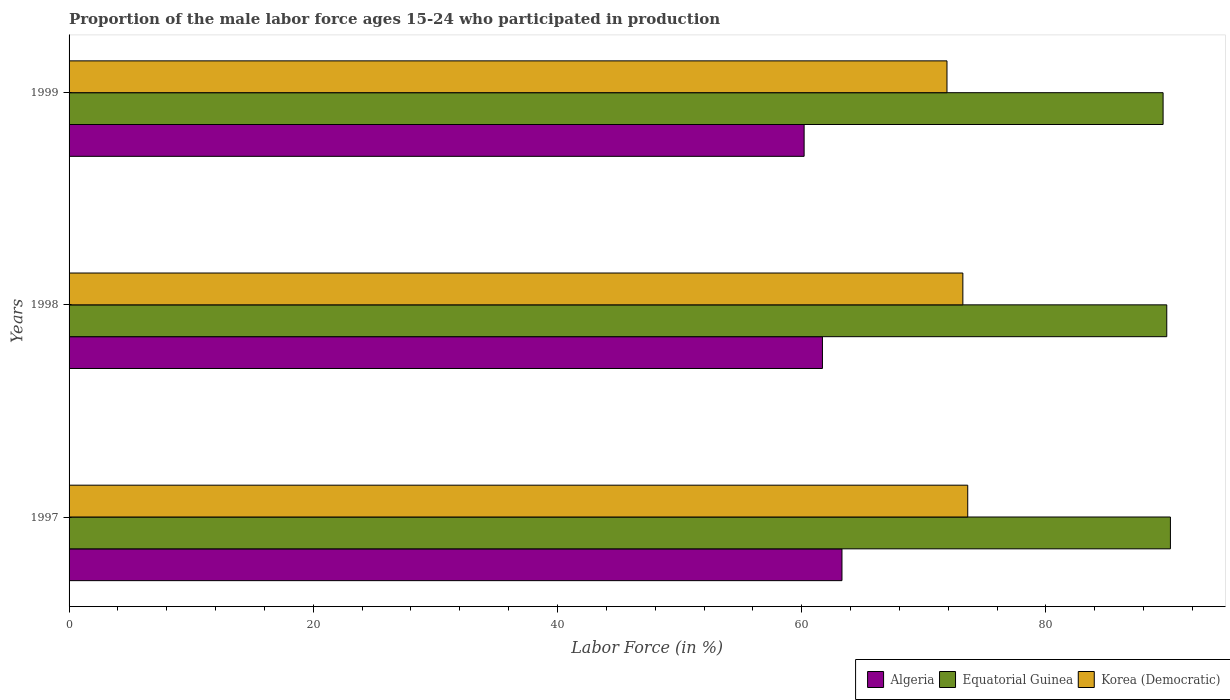Are the number of bars per tick equal to the number of legend labels?
Offer a very short reply. Yes. Are the number of bars on each tick of the Y-axis equal?
Your answer should be compact. Yes. How many bars are there on the 1st tick from the top?
Provide a short and direct response. 3. How many bars are there on the 2nd tick from the bottom?
Provide a succinct answer. 3. What is the proportion of the male labor force who participated in production in Algeria in 1997?
Your answer should be very brief. 63.3. Across all years, what is the maximum proportion of the male labor force who participated in production in Korea (Democratic)?
Keep it short and to the point. 73.6. Across all years, what is the minimum proportion of the male labor force who participated in production in Equatorial Guinea?
Provide a short and direct response. 89.6. In which year was the proportion of the male labor force who participated in production in Korea (Democratic) maximum?
Your response must be concise. 1997. In which year was the proportion of the male labor force who participated in production in Korea (Democratic) minimum?
Your answer should be very brief. 1999. What is the total proportion of the male labor force who participated in production in Equatorial Guinea in the graph?
Your response must be concise. 269.7. What is the difference between the proportion of the male labor force who participated in production in Algeria in 1998 and the proportion of the male labor force who participated in production in Equatorial Guinea in 1999?
Give a very brief answer. -27.9. What is the average proportion of the male labor force who participated in production in Algeria per year?
Provide a succinct answer. 61.73. In the year 1998, what is the difference between the proportion of the male labor force who participated in production in Algeria and proportion of the male labor force who participated in production in Equatorial Guinea?
Provide a succinct answer. -28.2. In how many years, is the proportion of the male labor force who participated in production in Equatorial Guinea greater than 72 %?
Your answer should be compact. 3. What is the ratio of the proportion of the male labor force who participated in production in Korea (Democratic) in 1997 to that in 1999?
Make the answer very short. 1.02. Is the proportion of the male labor force who participated in production in Equatorial Guinea in 1998 less than that in 1999?
Your answer should be very brief. No. What is the difference between the highest and the second highest proportion of the male labor force who participated in production in Korea (Democratic)?
Ensure brevity in your answer.  0.4. What is the difference between the highest and the lowest proportion of the male labor force who participated in production in Equatorial Guinea?
Offer a terse response. 0.6. Is the sum of the proportion of the male labor force who participated in production in Algeria in 1998 and 1999 greater than the maximum proportion of the male labor force who participated in production in Equatorial Guinea across all years?
Provide a succinct answer. Yes. What does the 2nd bar from the top in 1999 represents?
Offer a very short reply. Equatorial Guinea. What does the 1st bar from the bottom in 1997 represents?
Your answer should be compact. Algeria. Are all the bars in the graph horizontal?
Your response must be concise. Yes. How many years are there in the graph?
Ensure brevity in your answer.  3. What is the difference between two consecutive major ticks on the X-axis?
Your answer should be very brief. 20. Where does the legend appear in the graph?
Your response must be concise. Bottom right. What is the title of the graph?
Offer a terse response. Proportion of the male labor force ages 15-24 who participated in production. What is the label or title of the X-axis?
Keep it short and to the point. Labor Force (in %). What is the label or title of the Y-axis?
Your answer should be very brief. Years. What is the Labor Force (in %) in Algeria in 1997?
Keep it short and to the point. 63.3. What is the Labor Force (in %) in Equatorial Guinea in 1997?
Offer a terse response. 90.2. What is the Labor Force (in %) in Korea (Democratic) in 1997?
Keep it short and to the point. 73.6. What is the Labor Force (in %) in Algeria in 1998?
Provide a short and direct response. 61.7. What is the Labor Force (in %) in Equatorial Guinea in 1998?
Your answer should be compact. 89.9. What is the Labor Force (in %) in Korea (Democratic) in 1998?
Your answer should be very brief. 73.2. What is the Labor Force (in %) of Algeria in 1999?
Keep it short and to the point. 60.2. What is the Labor Force (in %) of Equatorial Guinea in 1999?
Give a very brief answer. 89.6. What is the Labor Force (in %) of Korea (Democratic) in 1999?
Offer a terse response. 71.9. Across all years, what is the maximum Labor Force (in %) of Algeria?
Offer a very short reply. 63.3. Across all years, what is the maximum Labor Force (in %) in Equatorial Guinea?
Your answer should be very brief. 90.2. Across all years, what is the maximum Labor Force (in %) in Korea (Democratic)?
Provide a succinct answer. 73.6. Across all years, what is the minimum Labor Force (in %) of Algeria?
Your answer should be compact. 60.2. Across all years, what is the minimum Labor Force (in %) of Equatorial Guinea?
Offer a very short reply. 89.6. Across all years, what is the minimum Labor Force (in %) of Korea (Democratic)?
Your answer should be very brief. 71.9. What is the total Labor Force (in %) of Algeria in the graph?
Give a very brief answer. 185.2. What is the total Labor Force (in %) of Equatorial Guinea in the graph?
Make the answer very short. 269.7. What is the total Labor Force (in %) in Korea (Democratic) in the graph?
Keep it short and to the point. 218.7. What is the difference between the Labor Force (in %) in Algeria in 1997 and that in 1998?
Make the answer very short. 1.6. What is the difference between the Labor Force (in %) of Equatorial Guinea in 1997 and that in 1999?
Ensure brevity in your answer.  0.6. What is the difference between the Labor Force (in %) in Korea (Democratic) in 1997 and that in 1999?
Offer a terse response. 1.7. What is the difference between the Labor Force (in %) in Equatorial Guinea in 1998 and that in 1999?
Your answer should be compact. 0.3. What is the difference between the Labor Force (in %) of Algeria in 1997 and the Labor Force (in %) of Equatorial Guinea in 1998?
Provide a succinct answer. -26.6. What is the difference between the Labor Force (in %) of Algeria in 1997 and the Labor Force (in %) of Korea (Democratic) in 1998?
Ensure brevity in your answer.  -9.9. What is the difference between the Labor Force (in %) of Equatorial Guinea in 1997 and the Labor Force (in %) of Korea (Democratic) in 1998?
Ensure brevity in your answer.  17. What is the difference between the Labor Force (in %) of Algeria in 1997 and the Labor Force (in %) of Equatorial Guinea in 1999?
Make the answer very short. -26.3. What is the difference between the Labor Force (in %) of Algeria in 1997 and the Labor Force (in %) of Korea (Democratic) in 1999?
Provide a short and direct response. -8.6. What is the difference between the Labor Force (in %) in Algeria in 1998 and the Labor Force (in %) in Equatorial Guinea in 1999?
Offer a very short reply. -27.9. What is the difference between the Labor Force (in %) of Algeria in 1998 and the Labor Force (in %) of Korea (Democratic) in 1999?
Offer a very short reply. -10.2. What is the average Labor Force (in %) in Algeria per year?
Your response must be concise. 61.73. What is the average Labor Force (in %) in Equatorial Guinea per year?
Provide a short and direct response. 89.9. What is the average Labor Force (in %) of Korea (Democratic) per year?
Give a very brief answer. 72.9. In the year 1997, what is the difference between the Labor Force (in %) of Algeria and Labor Force (in %) of Equatorial Guinea?
Your answer should be compact. -26.9. In the year 1998, what is the difference between the Labor Force (in %) of Algeria and Labor Force (in %) of Equatorial Guinea?
Ensure brevity in your answer.  -28.2. In the year 1998, what is the difference between the Labor Force (in %) in Algeria and Labor Force (in %) in Korea (Democratic)?
Your answer should be very brief. -11.5. In the year 1999, what is the difference between the Labor Force (in %) of Algeria and Labor Force (in %) of Equatorial Guinea?
Offer a very short reply. -29.4. What is the ratio of the Labor Force (in %) in Algeria in 1997 to that in 1998?
Offer a terse response. 1.03. What is the ratio of the Labor Force (in %) of Korea (Democratic) in 1997 to that in 1998?
Give a very brief answer. 1.01. What is the ratio of the Labor Force (in %) in Algeria in 1997 to that in 1999?
Give a very brief answer. 1.05. What is the ratio of the Labor Force (in %) of Equatorial Guinea in 1997 to that in 1999?
Offer a terse response. 1.01. What is the ratio of the Labor Force (in %) of Korea (Democratic) in 1997 to that in 1999?
Make the answer very short. 1.02. What is the ratio of the Labor Force (in %) of Algeria in 1998 to that in 1999?
Keep it short and to the point. 1.02. What is the ratio of the Labor Force (in %) in Korea (Democratic) in 1998 to that in 1999?
Keep it short and to the point. 1.02. What is the difference between the highest and the second highest Labor Force (in %) in Algeria?
Ensure brevity in your answer.  1.6. What is the difference between the highest and the second highest Labor Force (in %) in Equatorial Guinea?
Provide a succinct answer. 0.3. What is the difference between the highest and the lowest Labor Force (in %) of Equatorial Guinea?
Give a very brief answer. 0.6. 